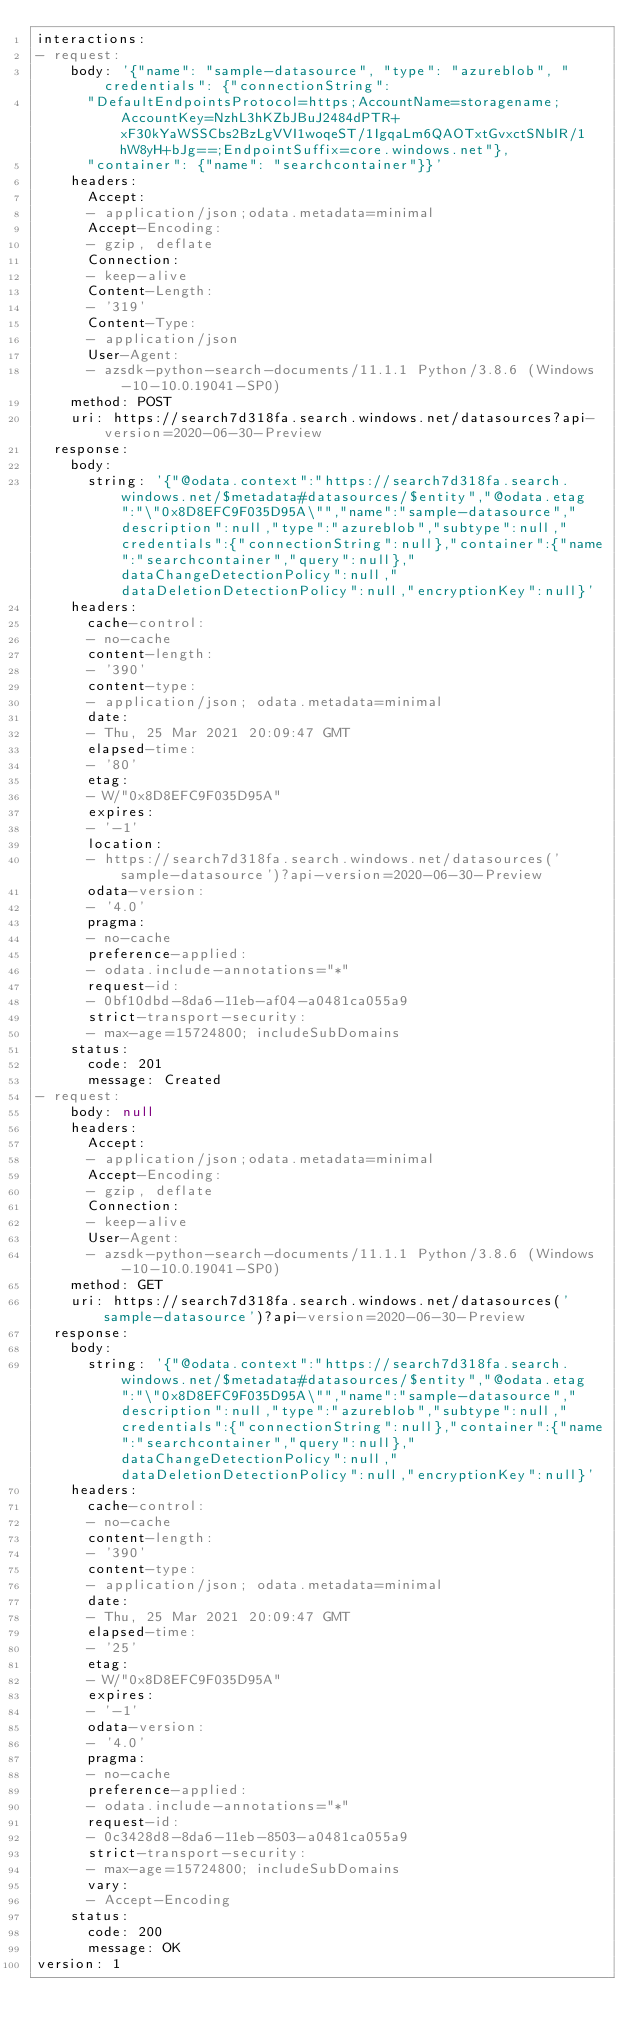<code> <loc_0><loc_0><loc_500><loc_500><_YAML_>interactions:
- request:
    body: '{"name": "sample-datasource", "type": "azureblob", "credentials": {"connectionString":
      "DefaultEndpointsProtocol=https;AccountName=storagename;AccountKey=NzhL3hKZbJBuJ2484dPTR+xF30kYaWSSCbs2BzLgVVI1woqeST/1IgqaLm6QAOTxtGvxctSNbIR/1hW8yH+bJg==;EndpointSuffix=core.windows.net"},
      "container": {"name": "searchcontainer"}}'
    headers:
      Accept:
      - application/json;odata.metadata=minimal
      Accept-Encoding:
      - gzip, deflate
      Connection:
      - keep-alive
      Content-Length:
      - '319'
      Content-Type:
      - application/json
      User-Agent:
      - azsdk-python-search-documents/11.1.1 Python/3.8.6 (Windows-10-10.0.19041-SP0)
    method: POST
    uri: https://search7d318fa.search.windows.net/datasources?api-version=2020-06-30-Preview
  response:
    body:
      string: '{"@odata.context":"https://search7d318fa.search.windows.net/$metadata#datasources/$entity","@odata.etag":"\"0x8D8EFC9F035D95A\"","name":"sample-datasource","description":null,"type":"azureblob","subtype":null,"credentials":{"connectionString":null},"container":{"name":"searchcontainer","query":null},"dataChangeDetectionPolicy":null,"dataDeletionDetectionPolicy":null,"encryptionKey":null}'
    headers:
      cache-control:
      - no-cache
      content-length:
      - '390'
      content-type:
      - application/json; odata.metadata=minimal
      date:
      - Thu, 25 Mar 2021 20:09:47 GMT
      elapsed-time:
      - '80'
      etag:
      - W/"0x8D8EFC9F035D95A"
      expires:
      - '-1'
      location:
      - https://search7d318fa.search.windows.net/datasources('sample-datasource')?api-version=2020-06-30-Preview
      odata-version:
      - '4.0'
      pragma:
      - no-cache
      preference-applied:
      - odata.include-annotations="*"
      request-id:
      - 0bf10dbd-8da6-11eb-af04-a0481ca055a9
      strict-transport-security:
      - max-age=15724800; includeSubDomains
    status:
      code: 201
      message: Created
- request:
    body: null
    headers:
      Accept:
      - application/json;odata.metadata=minimal
      Accept-Encoding:
      - gzip, deflate
      Connection:
      - keep-alive
      User-Agent:
      - azsdk-python-search-documents/11.1.1 Python/3.8.6 (Windows-10-10.0.19041-SP0)
    method: GET
    uri: https://search7d318fa.search.windows.net/datasources('sample-datasource')?api-version=2020-06-30-Preview
  response:
    body:
      string: '{"@odata.context":"https://search7d318fa.search.windows.net/$metadata#datasources/$entity","@odata.etag":"\"0x8D8EFC9F035D95A\"","name":"sample-datasource","description":null,"type":"azureblob","subtype":null,"credentials":{"connectionString":null},"container":{"name":"searchcontainer","query":null},"dataChangeDetectionPolicy":null,"dataDeletionDetectionPolicy":null,"encryptionKey":null}'
    headers:
      cache-control:
      - no-cache
      content-length:
      - '390'
      content-type:
      - application/json; odata.metadata=minimal
      date:
      - Thu, 25 Mar 2021 20:09:47 GMT
      elapsed-time:
      - '25'
      etag:
      - W/"0x8D8EFC9F035D95A"
      expires:
      - '-1'
      odata-version:
      - '4.0'
      pragma:
      - no-cache
      preference-applied:
      - odata.include-annotations="*"
      request-id:
      - 0c3428d8-8da6-11eb-8503-a0481ca055a9
      strict-transport-security:
      - max-age=15724800; includeSubDomains
      vary:
      - Accept-Encoding
    status:
      code: 200
      message: OK
version: 1
</code> 